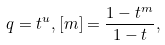<formula> <loc_0><loc_0><loc_500><loc_500>q = t ^ { u } , [ m ] = \frac { 1 - t ^ { m } } { 1 - t } ,</formula> 